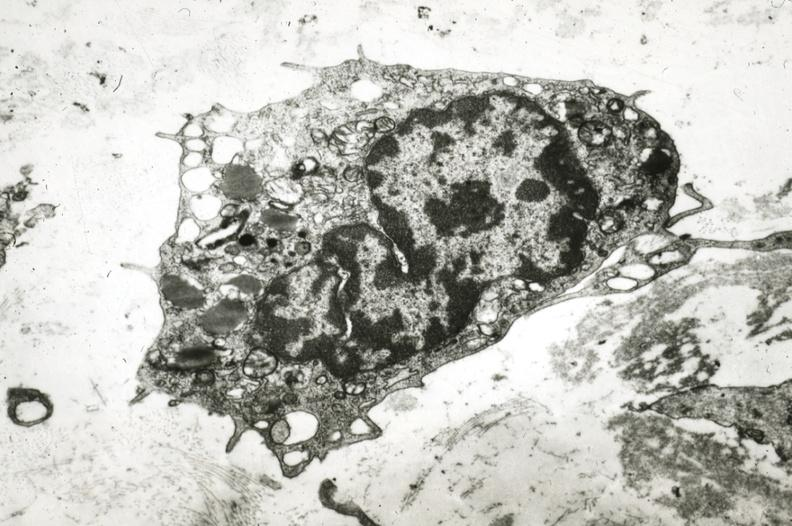what is present?
Answer the question using a single word or phrase. Cardiovascular 